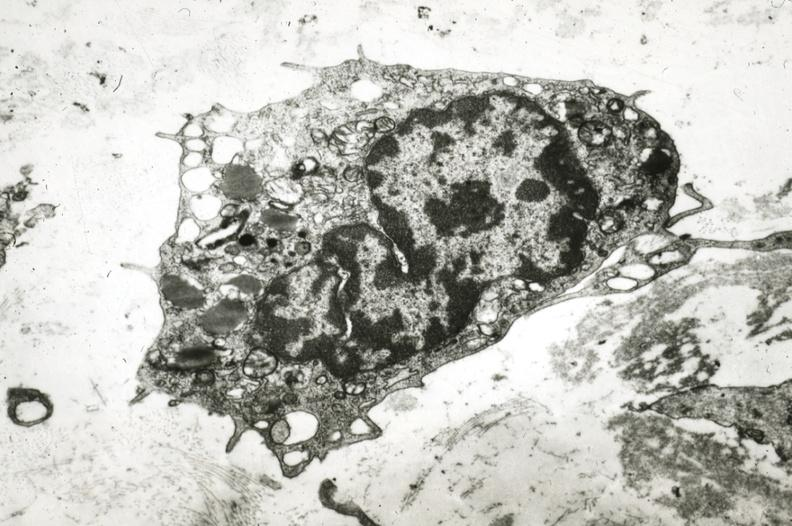what is present?
Answer the question using a single word or phrase. Cardiovascular 